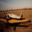What could be the impact of using this type of jet airliner on the environment and what measures can be taken to mitigate these impacts? Commercial jet airliners, like the one shown in the image, significantly impact the environment mainly through high levels of carbon emissions and noise pollution. Mitigation measures include developing and using more fuel-efficient engines, incorporating sustainable aviation fuels, and enhancing aerodynamics to reduce fuel consumption. Additionally, airlines can invest in carbon offset programs that contribute to environmental projects to balance out their carbon footprints. Implementing stricter noise regulations and developing technology for quieter engines can also help lessen noise pollution around airports. 